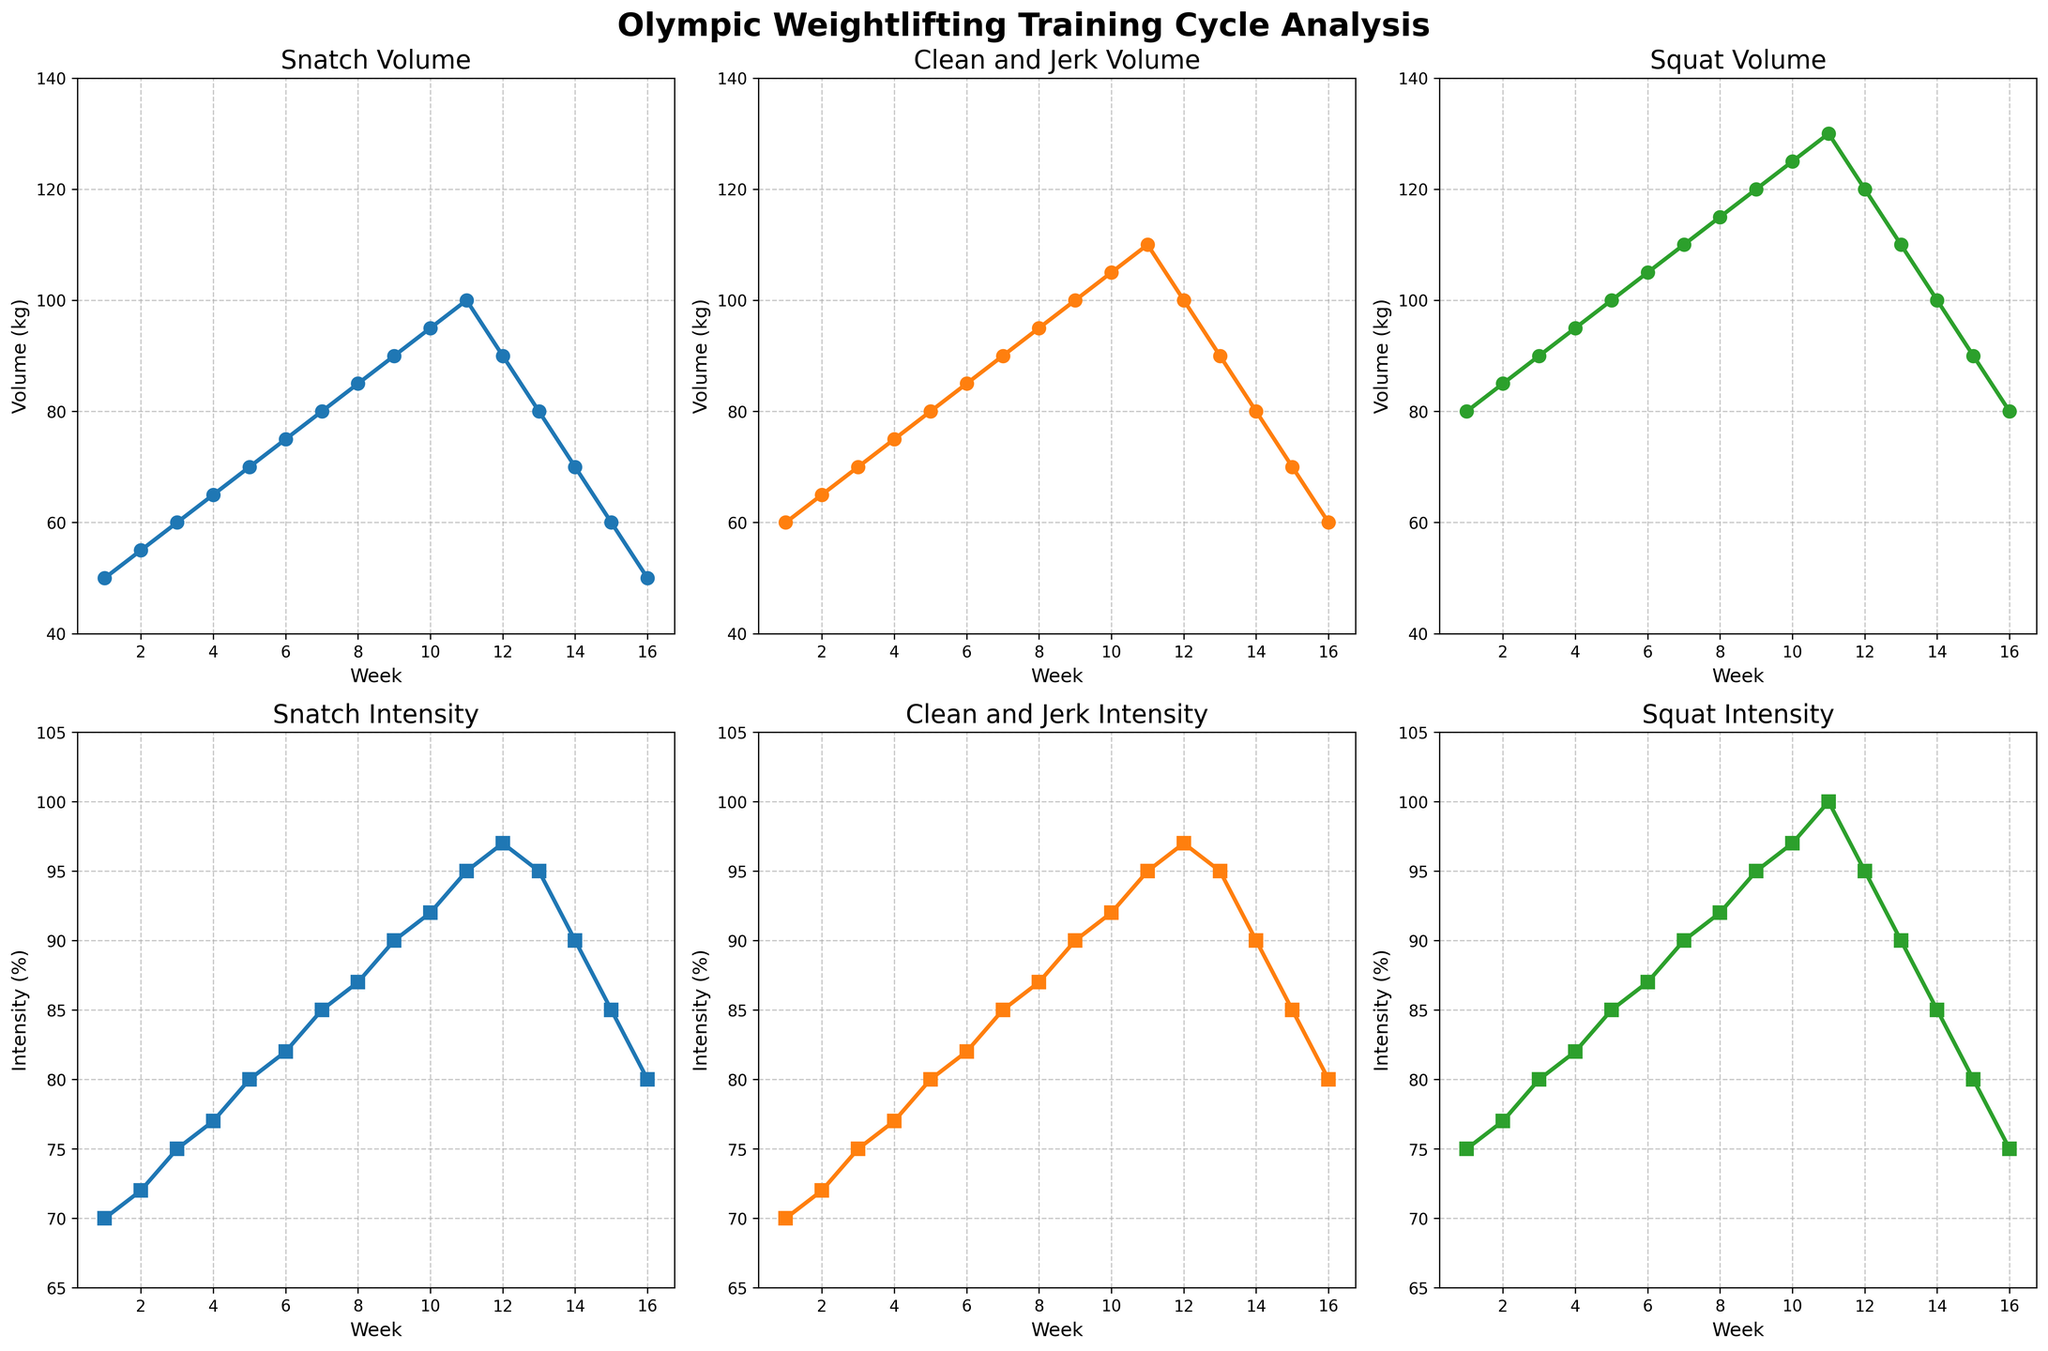What is the title of the figure? The title of the figure is placed at the top center of the figure. It reads "Olympic Weightlifting Training Cycle Analysis".
Answer: Olympic Weightlifting Training Cycle Analysis Which lift has the highest volume in Week 10? In Week 10, the volume plot for Snatch, Clean and Jerk, and Squat can be observed. The plot for Squat reaches the high point of 125 kg, which is the highest among all lifts.
Answer: Squat What is the maximum intensity percentage for the Snatch lift throughout the cycle? The maximum Snatch intensity percentage can be observed on the Snatch intensity plot in the second row. It peaks at 97% in Week 12.
Answer: 97% During which week do all the lifts have the same volume? Comparing the Volume plots across all three lifts, it is evident that Week 16 has Snatch, Clean and Jerk, and Squat volumes all at 50, 60, and 80 kg respectively.
Answer: Week 16 How does the Squat volume change from Week 5 to Week 8? From Week 5 (100 kg) to Week 8 (115 kg), the Squat volume shows an increasing trend. The increase each week observed in the data plot is incremental and upwards.
Answer: Increases In Week 13, which lift has the highest volume? Looking at the volume plots for Week 13, the Squat still dominates with a volume of 110 kg, higher than the Snatch and Clean and Jerk.
Answer: Squat What is the overall trend of the Clean and Jerk intensity over the 16 weeks? Observing the Clean and Jerk intensity plot, there is an increasing trend from Week 1 to Week 11, peaking at 95%. A decline follows to 80% by Week 16 indicating an upward trend before tapering off.
Answer: Increasing then decreasing Compare the intensity peaks of Snatch, Clean and Jerk, and Squat. Which one reaches its peak first? The Snatch, Clean and Jerk, and Squat intensity plots all peak but at different points. Snatch and Clean and Jerk peak at Week 12, whereas Squat intensity hits its peak at Week 11. Thus, Squat reaches its peak earlier.
Answer: Squat 